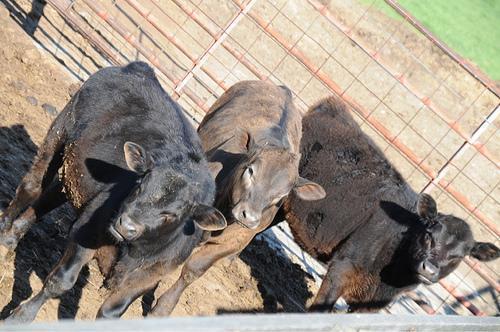How many animals are shown?
Give a very brief answer. 3. 